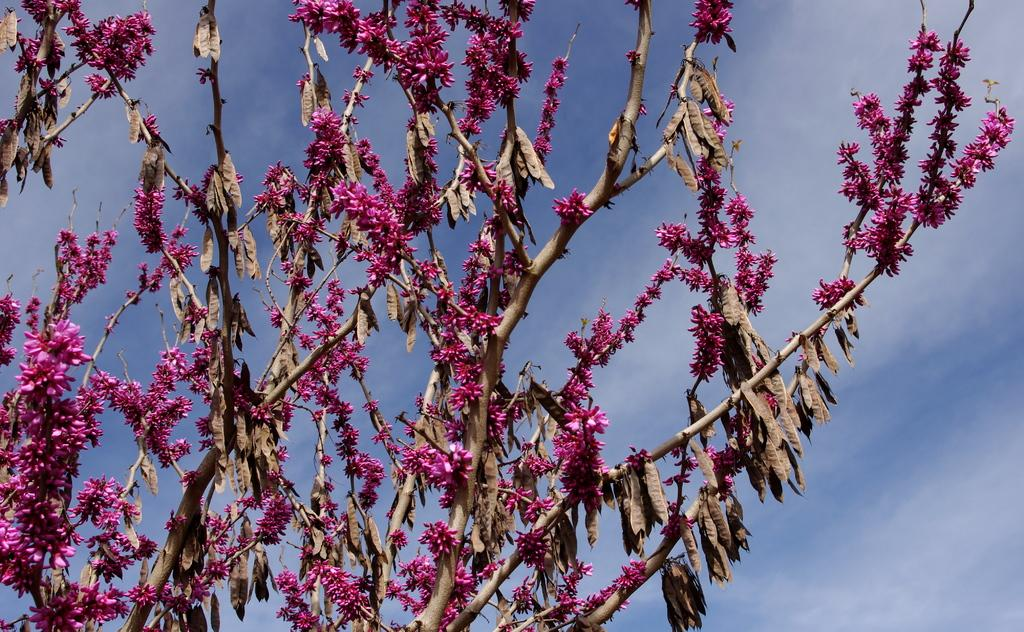What type of plants can be seen in the image? There are flowers and leaves in the image. What is visible at the top of the image? The sky is visible at the top of the image. What type of creature can be seen interacting with the flowers in the image? There is no creature present in the image; it only features flowers, leaves, and the sky. What system is responsible for the growth of the flowers in the image? The image does not provide information about the system responsible for the growth of the flowers. 